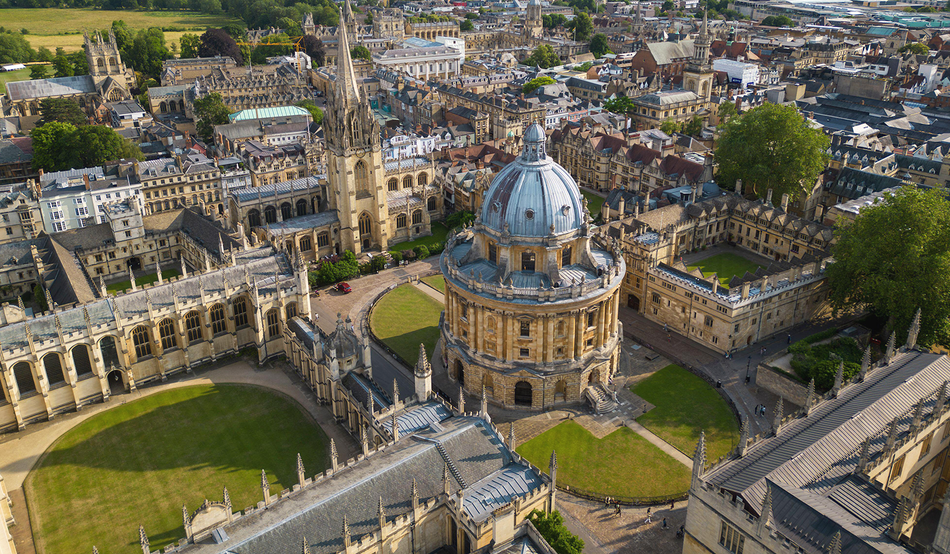What do you see happening in this image?
 The image presents a breathtaking aerial view of Oxford University, one of the world's oldest and most prestigious educational institutions. The focal point of the image is the Radcliffe Camera, a distinctive circular library topped with a grand dome. This architectural marvel, constructed from light-colored stone, stands out amidst the surrounding buildings.

The university's structures, adorned with ornate details and towering spires, exude a sense of historical grandeur. These buildings are arranged around well-manicured courtyards, their greenery providing a vibrant contrast to the stone edifices.

The high-angle perspective of the image offers a comprehensive view of the university layout, allowing one to appreciate the intricate design and symmetry of the campus. The image captures not just a place, but a symbol of academic excellence and centuries-old traditions. 